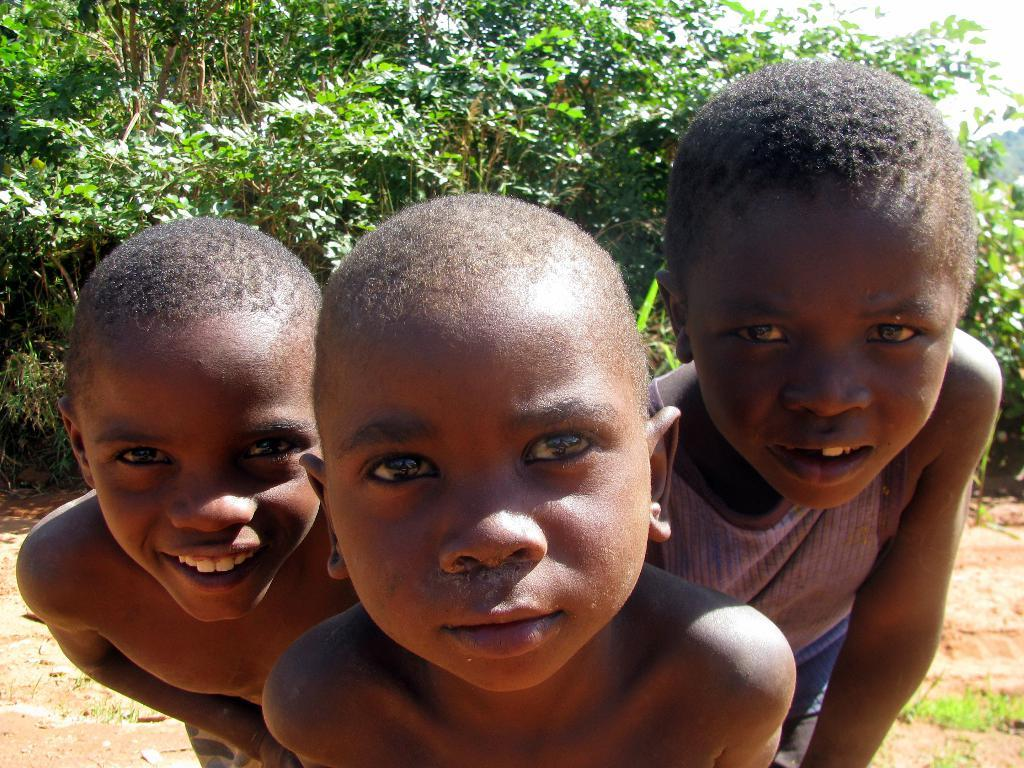How many children are present in the image? There are three kids in the image. What is the location of the kids in the image? The kids are standing on a land. What can be seen in the background of the image? There are trees in the background of the image. What type of underwear is the kid on the left wearing in the image? There is no information about the kids' underwear in the image, so it cannot be determined. 